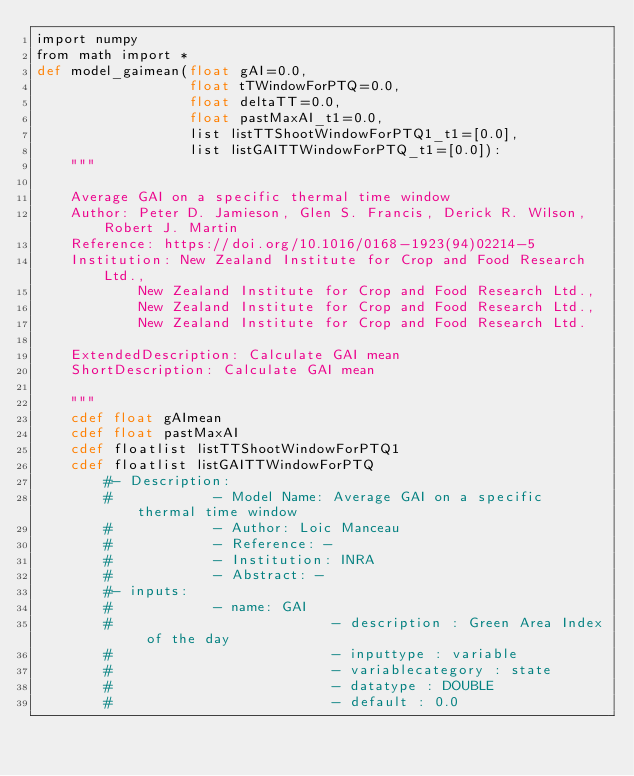<code> <loc_0><loc_0><loc_500><loc_500><_Cython_>import numpy 
from math import *
def model_gaimean(float gAI=0.0,
                  float tTWindowForPTQ=0.0,
                  float deltaTT=0.0,
                  float pastMaxAI_t1=0.0,
                  list listTTShootWindowForPTQ1_t1=[0.0],
                  list listGAITTWindowForPTQ_t1=[0.0]):
    """

    Average GAI on a specific thermal time window
    Author: Peter D. Jamieson, Glen S. Francis, Derick R. Wilson, Robert J. Martin
    Reference: https://doi.org/10.1016/0168-1923(94)02214-5
    Institution: New Zealand Institute for Crop and Food Research Ltd.,
            New Zealand Institute for Crop and Food Research Ltd.,
            New Zealand Institute for Crop and Food Research Ltd.,
            New Zealand Institute for Crop and Food Research Ltd.
        
    ExtendedDescription: Calculate GAI mean
    ShortDescription: Calculate GAI mean

    """
    cdef float gAImean
    cdef float pastMaxAI
    cdef floatlist listTTShootWindowForPTQ1
    cdef floatlist listGAITTWindowForPTQ
        #- Description:
        #            - Model Name: Average GAI on a specific thermal time window
        #            - Author: Loic Manceau
        #            - Reference: -
        #            - Institution: INRA
        #            - Abstract: -
        #- inputs:
        #            - name: GAI
        #                          - description : Green Area Index of the day
        #                          - inputtype : variable
        #                          - variablecategory : state
        #                          - datatype : DOUBLE
        #                          - default : 0.0</code> 